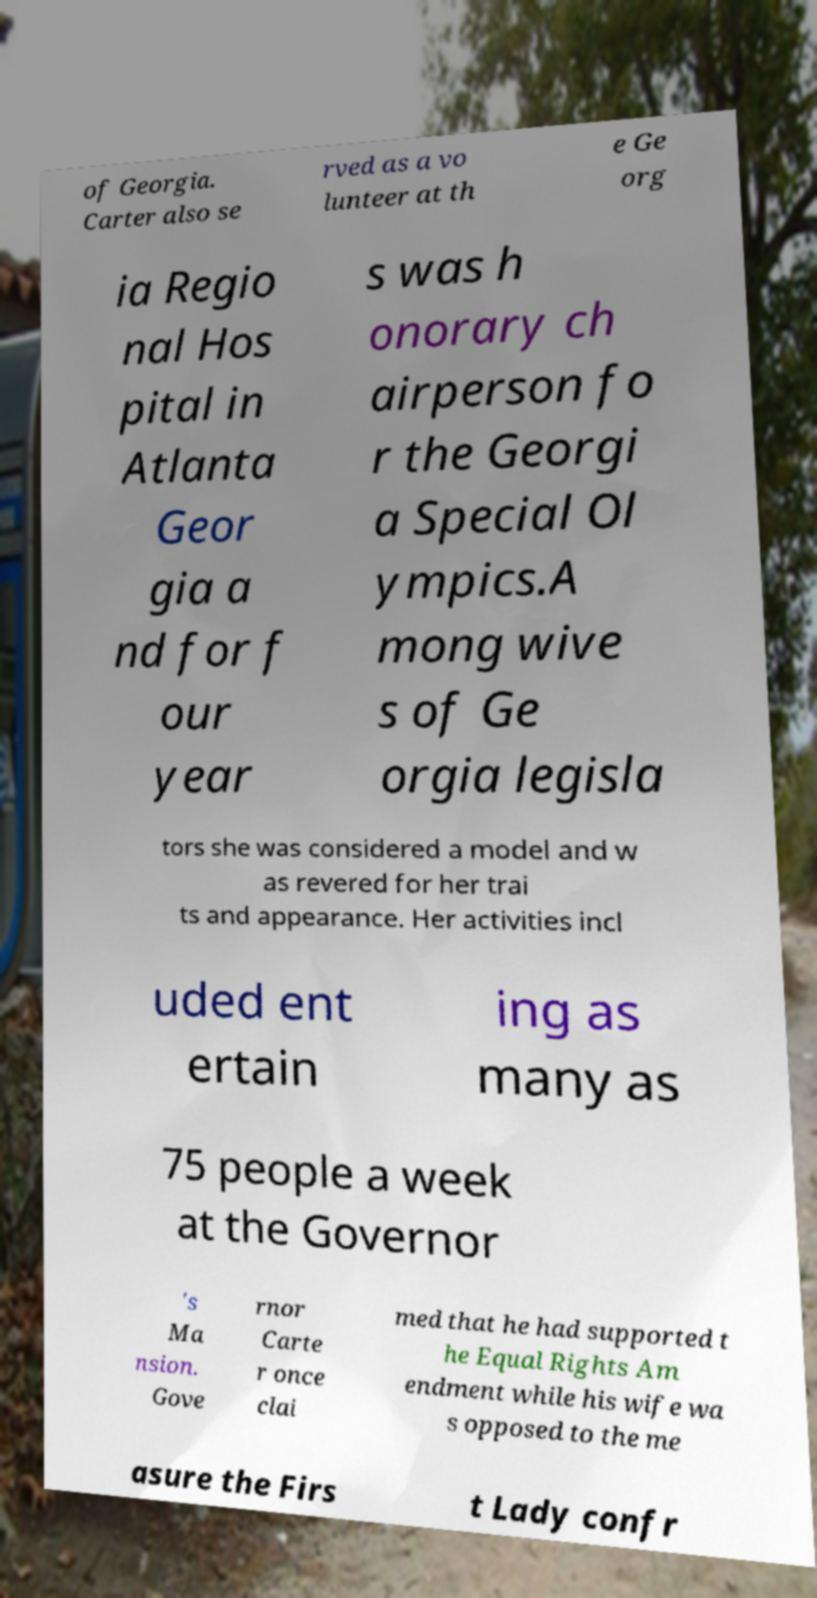Please read and relay the text visible in this image. What does it say? of Georgia. Carter also se rved as a vo lunteer at th e Ge org ia Regio nal Hos pital in Atlanta Geor gia a nd for f our year s was h onorary ch airperson fo r the Georgi a Special Ol ympics.A mong wive s of Ge orgia legisla tors she was considered a model and w as revered for her trai ts and appearance. Her activities incl uded ent ertain ing as many as 75 people a week at the Governor 's Ma nsion. Gove rnor Carte r once clai med that he had supported t he Equal Rights Am endment while his wife wa s opposed to the me asure the Firs t Lady confr 